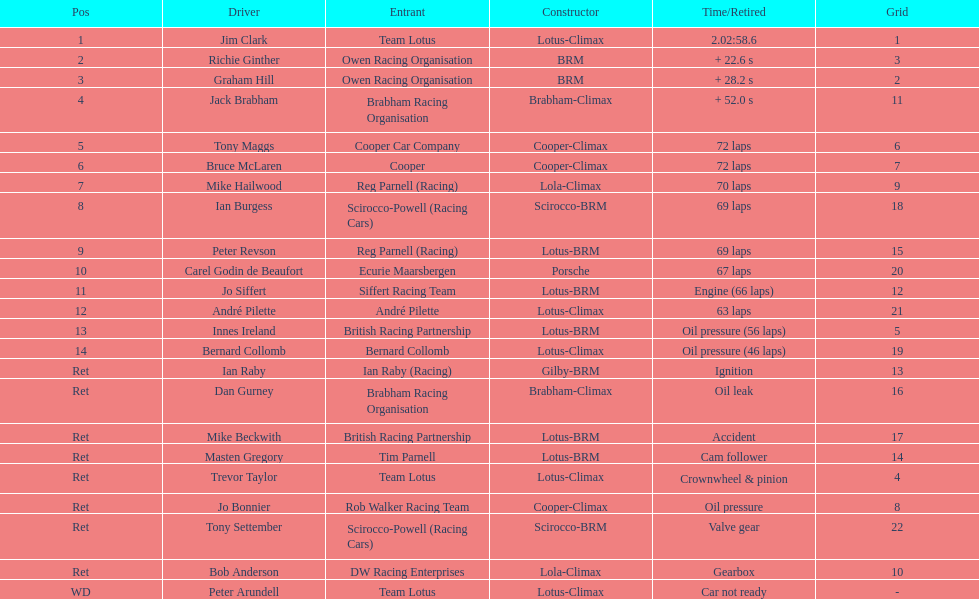How many race participants had cooper-climax as their maker? 3. 